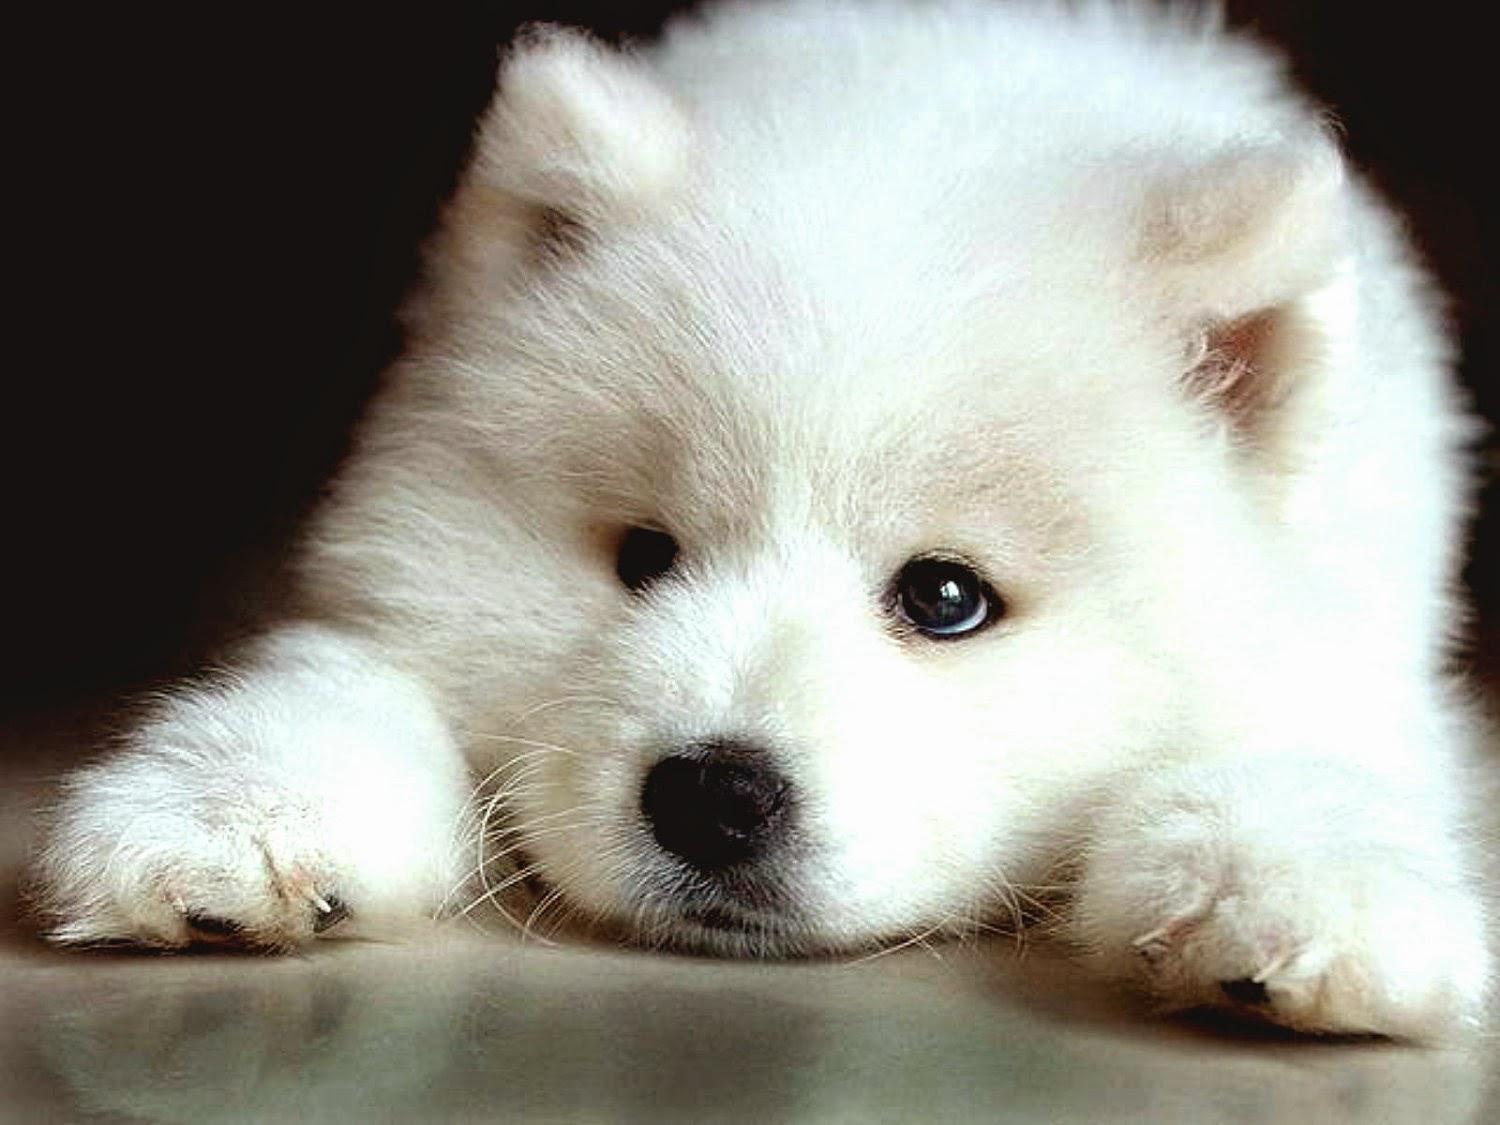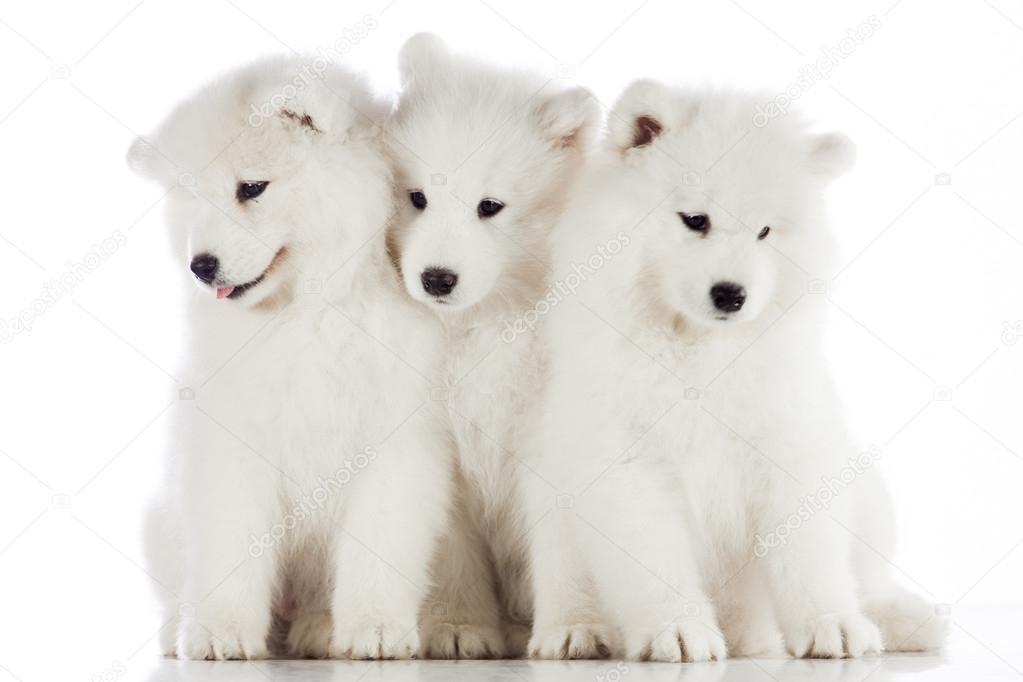The first image is the image on the left, the second image is the image on the right. Evaluate the accuracy of this statement regarding the images: "One image shows three same-sized white puppies posed side-by-side.". Is it true? Answer yes or no. Yes. The first image is the image on the left, the second image is the image on the right. Given the left and right images, does the statement "All four dogs are white." hold true? Answer yes or no. Yes. 